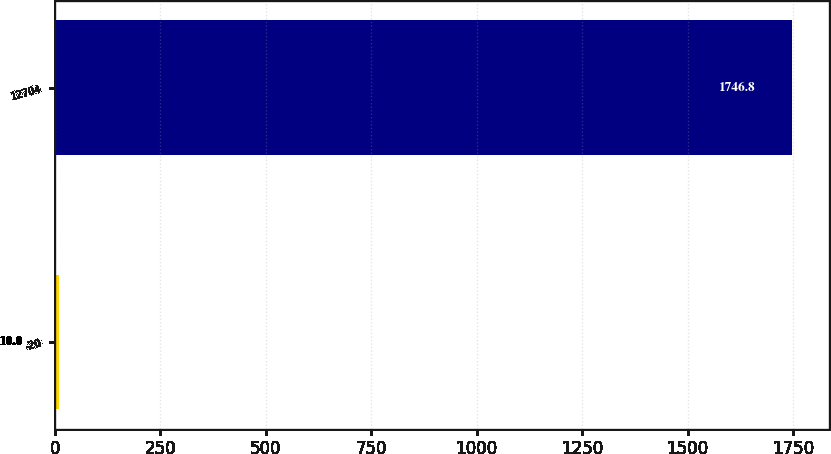<chart> <loc_0><loc_0><loc_500><loc_500><bar_chart><fcel>-20<fcel>12704<nl><fcel>10<fcel>1746.8<nl></chart> 